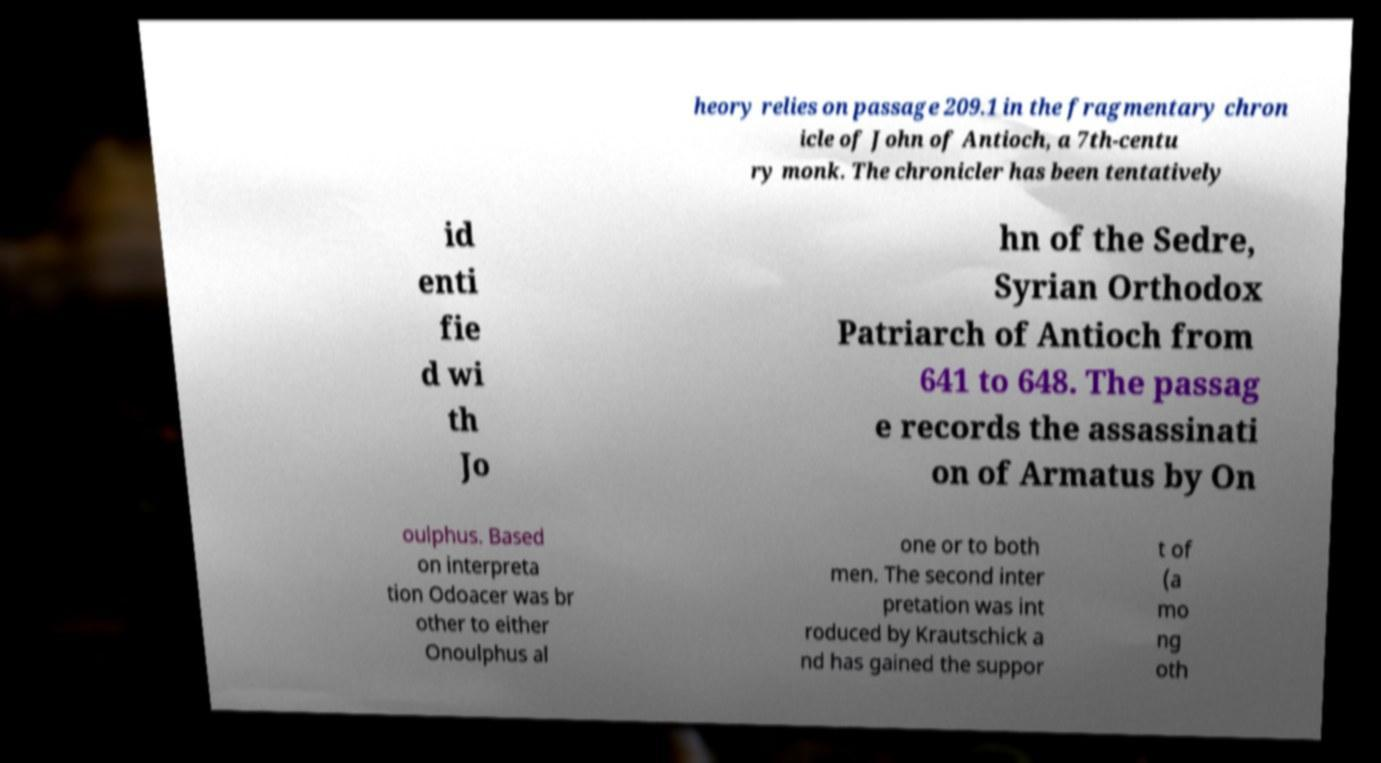I need the written content from this picture converted into text. Can you do that? heory relies on passage 209.1 in the fragmentary chron icle of John of Antioch, a 7th-centu ry monk. The chronicler has been tentatively id enti fie d wi th Jo hn of the Sedre, Syrian Orthodox Patriarch of Antioch from 641 to 648. The passag e records the assassinati on of Armatus by On oulphus. Based on interpreta tion Odoacer was br other to either Onoulphus al one or to both men. The second inter pretation was int roduced by Krautschick a nd has gained the suppor t of (a mo ng oth 